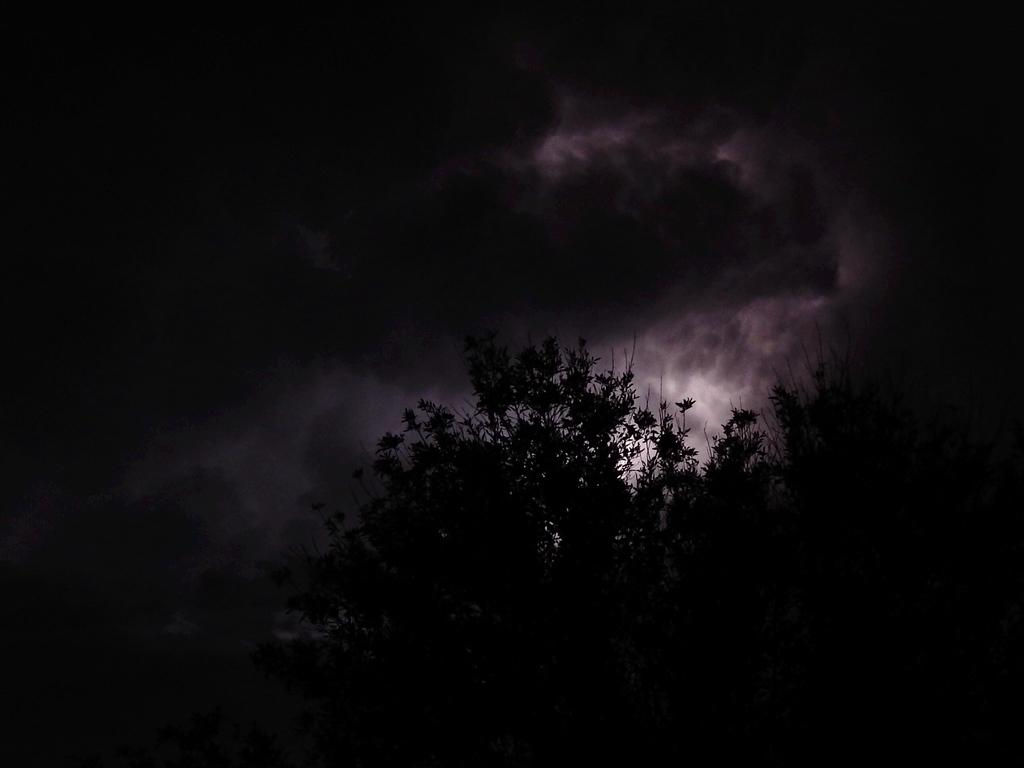What type of natural element is present in the image? There is a tree in the image. What part of the natural environment is visible in the image? The sky is visible in the image. What can be seen in the sky? There are clouds and the moon visible in the sky. How would you describe the appearance of the sky? The remaining sky is dark. What type of fuel is being used to power the tree in the image? There is no fuel being used to power the tree in the image, as trees are living organisms that do not require fuel to function. 